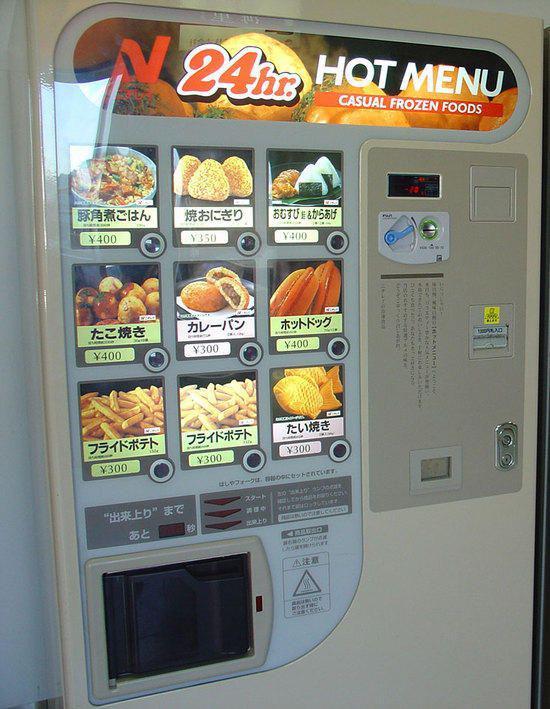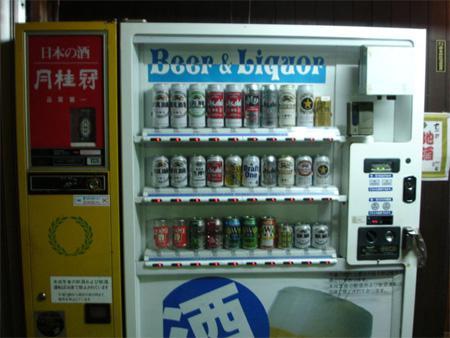The first image is the image on the left, the second image is the image on the right. For the images displayed, is the sentence "Each image depicts a long row of outdoor red, white, and blue vending machines parked in front of a green area, with pavement in front." factually correct? Answer yes or no. No. The first image is the image on the left, the second image is the image on the right. Given the left and right images, does the statement "Red canapes cover some of the machines outside." hold true? Answer yes or no. No. 